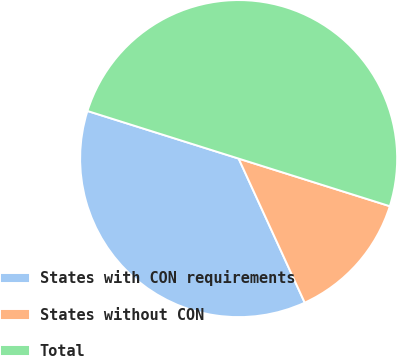<chart> <loc_0><loc_0><loc_500><loc_500><pie_chart><fcel>States with CON requirements<fcel>States without CON<fcel>Total<nl><fcel>36.7%<fcel>13.3%<fcel>50.0%<nl></chart> 